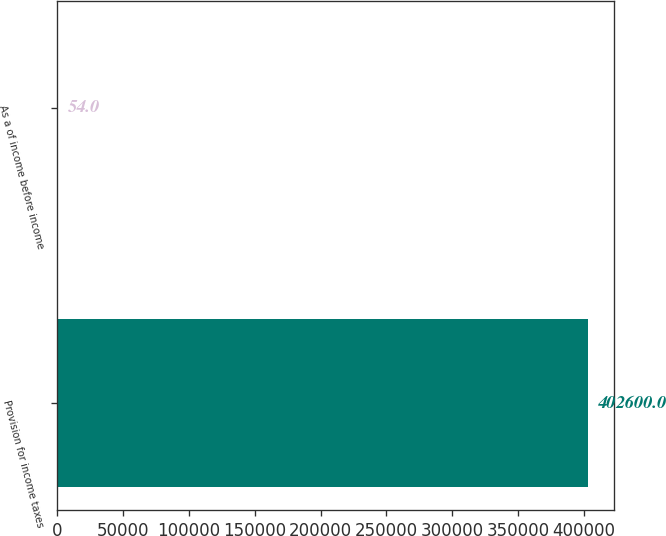Convert chart to OTSL. <chart><loc_0><loc_0><loc_500><loc_500><bar_chart><fcel>Provision for income taxes<fcel>As a of income before income<nl><fcel>402600<fcel>54<nl></chart> 